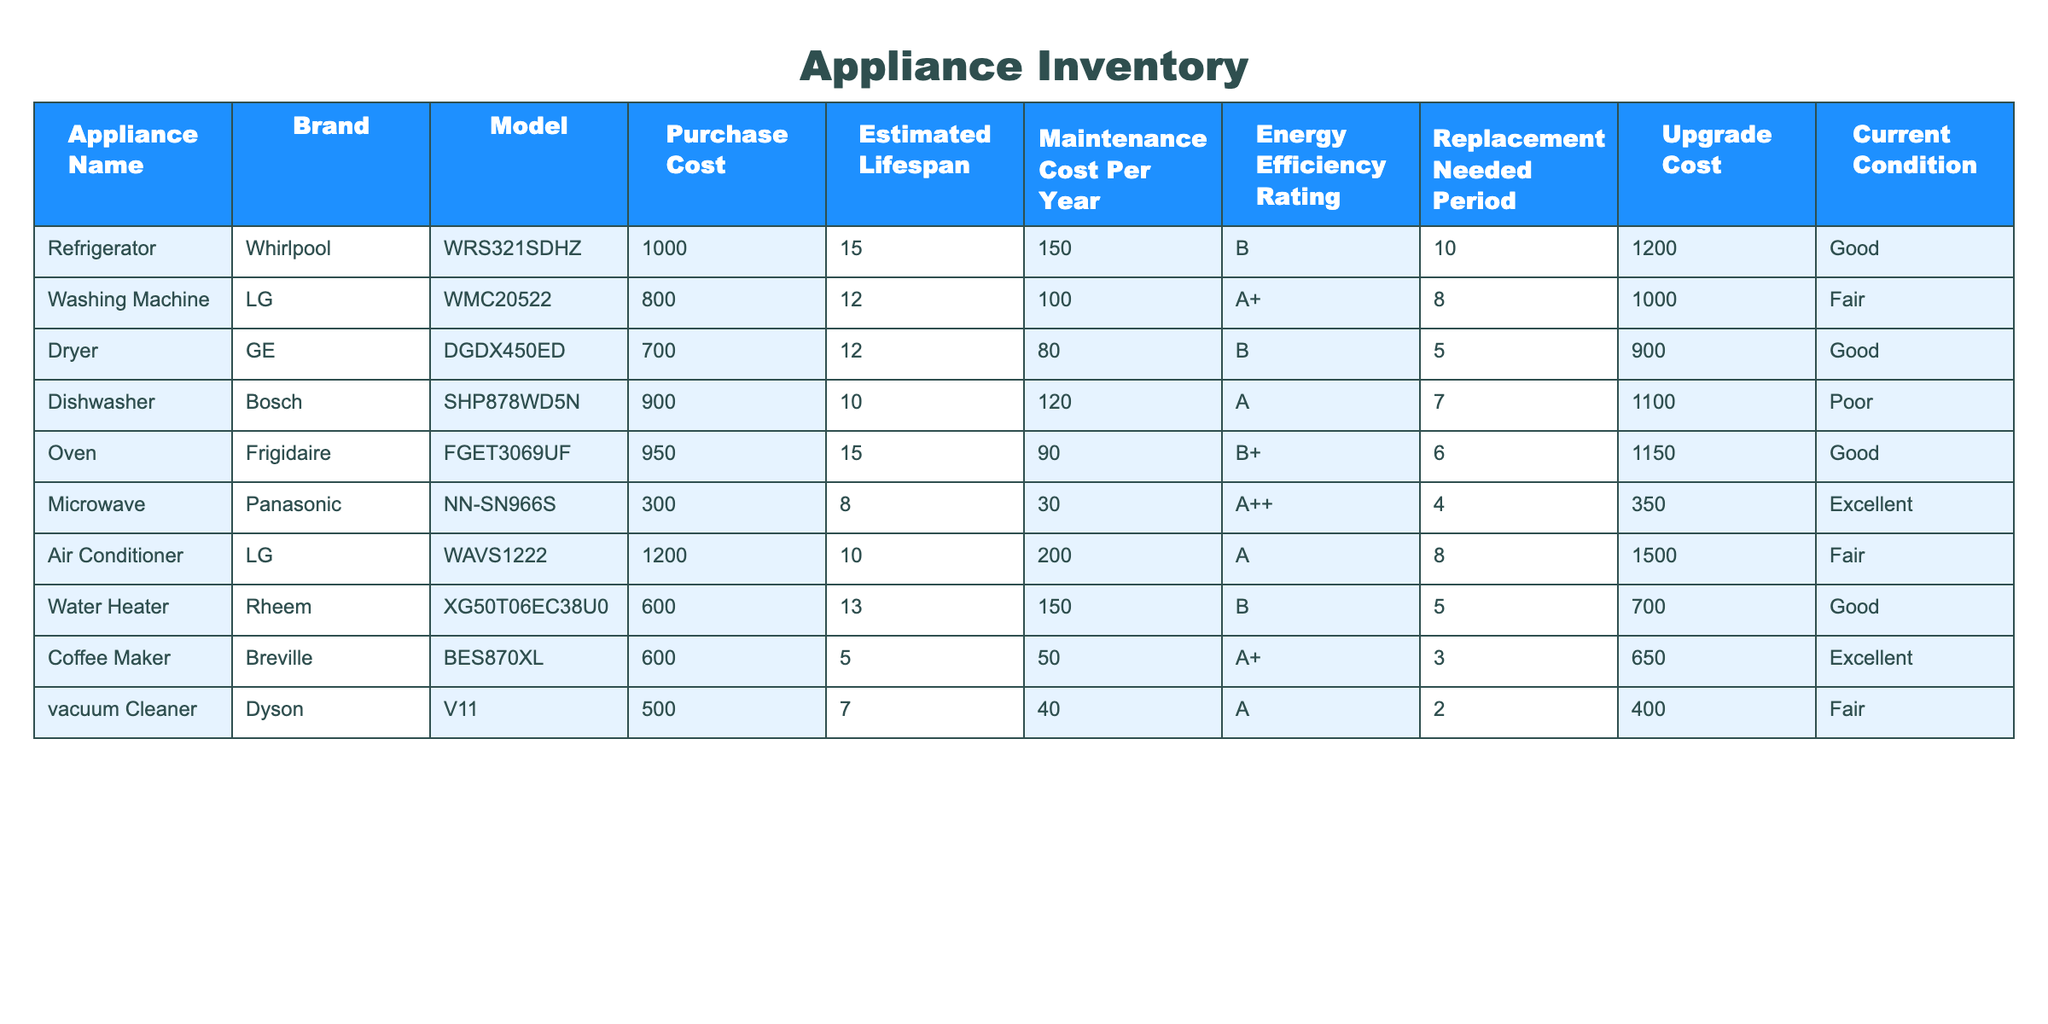What is the purchase cost of the Dishwasher? The purchase cost of the Dishwasher is listed in the table under the "Purchase Cost" column. By looking at the row for the Dishwasher, we see it has a purchase cost of 900.
Answer: 900 What is the estimated lifespan of the Washing Machine? The estimated lifespan of an appliance is also present in the table. By checking the row for the Washing Machine, we find that its estimated lifespan is 12 years.
Answer: 12 Which appliance has the highest upgrade cost? We need to look through the "Upgrade Cost" column to identify the appliance with the highest value. The Air Conditioner has the highest upgrade cost of 1500.
Answer: 1500 Is the Microwave in excellent condition? The condition of each appliance is mentioned in the "Current Condition" column. The Microwave is listed as being in excellent condition, which confirms the fact.
Answer: Yes What is the average maintenance cost per year for all appliances? To calculate the average maintenance cost, we sum all maintenance costs listed and divide by the total number of appliances. The total maintenance cost is 150 + 100 + 80 + 120 + 90 + 30 + 200 + 150 + 50 + 40 = 1110, and there are 10 appliances, so the average is 1110/10 = 111.
Answer: 111 Which appliance has the lowest energy efficiency rating? A comparison of the "Energy Efficiency Rating" column will show which appliance ranks the lowest. The Dryer, with a rating of B, has the lowest efficiency rating compared to others.
Answer: B How much more does it cost to upgrade the Dishwasher compared to the Coffee Maker? We find the upgrade costs for both appliances in their respective rows. The upgrade cost for the Dishwasher is 1100, and for the Coffee Maker, it is 650. The difference is 1100 - 650 = 450.
Answer: 450 Is there any appliance that needs replacement in less than 5 years? Checking the "Replacement Needed Period," we see the vacuum cleaner with a period of 2 years and the Dryer with a period of 5 years. Hence, yes, the vacuum cleaner needs replacement in less than 5 years.
Answer: Yes What is the total purchase cost of all appliances in good condition? We will collect the purchase costs of appliances marked as "Good" in the Current Condition column. The Refrigerator (1000), Dryer (700), Oven (950), and Water Heater (600) contribute to a total of 1000 + 700 + 950 + 600 = 3250.
Answer: 3250 